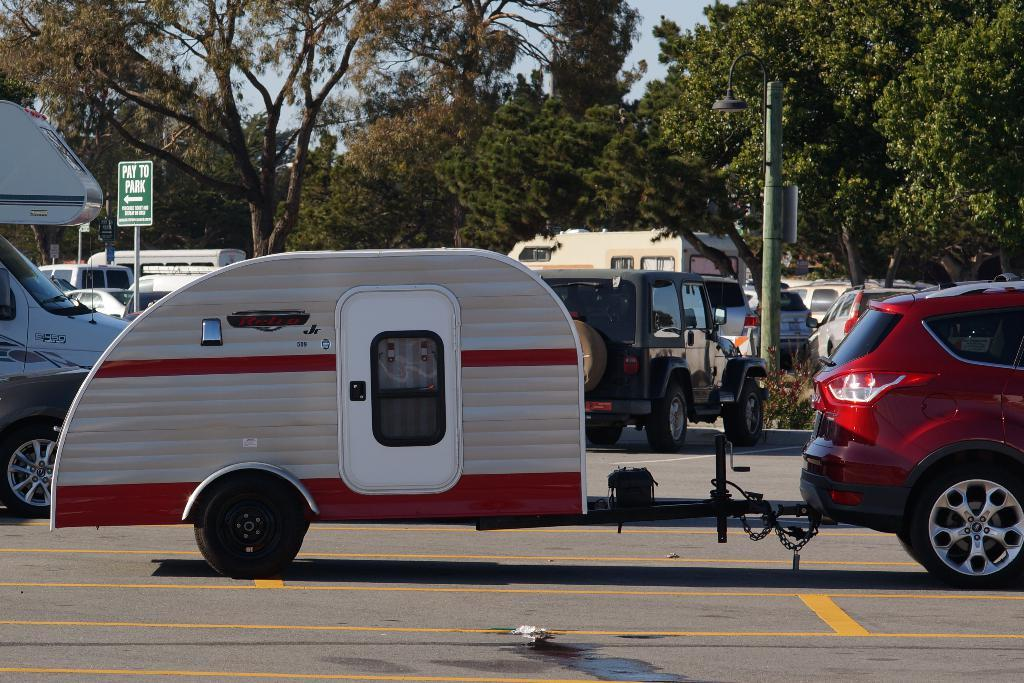<image>
Provide a brief description of the given image. A teardrop camper, a something Jr. is being towed by a red SUV. 